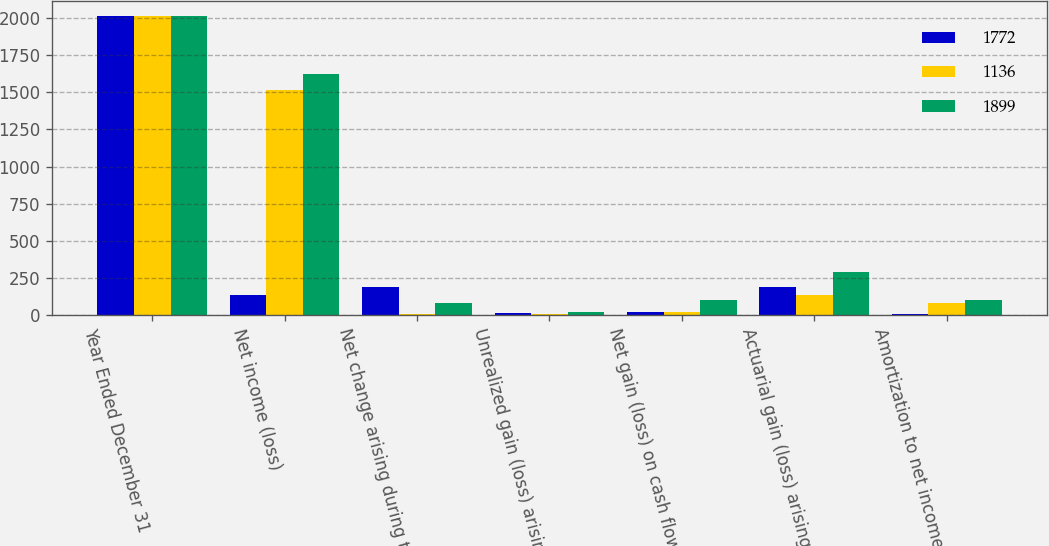<chart> <loc_0><loc_0><loc_500><loc_500><stacked_bar_chart><ecel><fcel>Year Ended December 31<fcel>Net income (loss)<fcel>Net change arising during the<fcel>Unrealized gain (loss) arising<fcel>Net gain (loss) on cash flow<fcel>Actuarial gain (loss) arising<fcel>Amortization to net income<nl><fcel>1772<fcel>2018<fcel>134<fcel>191<fcel>11<fcel>16<fcel>186<fcel>5<nl><fcel>1136<fcel>2017<fcel>1513<fcel>3<fcel>8<fcel>22<fcel>134<fcel>80<nl><fcel>1899<fcel>2016<fcel>1627<fcel>83<fcel>21<fcel>101<fcel>289<fcel>102<nl></chart> 